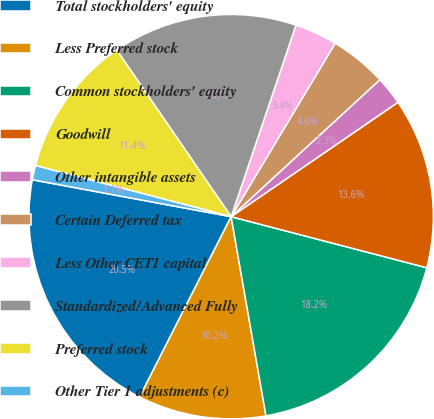Convert chart. <chart><loc_0><loc_0><loc_500><loc_500><pie_chart><fcel>Total stockholders' equity<fcel>Less Preferred stock<fcel>Common stockholders' equity<fcel>Goodwill<fcel>Other intangible assets<fcel>Certain Deferred tax<fcel>Less Other CET1 capital<fcel>Standardized/Advanced Fully<fcel>Preferred stock<fcel>Other Tier 1 adjustments (c)<nl><fcel>20.45%<fcel>10.23%<fcel>18.18%<fcel>13.63%<fcel>2.28%<fcel>4.55%<fcel>3.41%<fcel>14.77%<fcel>11.36%<fcel>1.14%<nl></chart> 